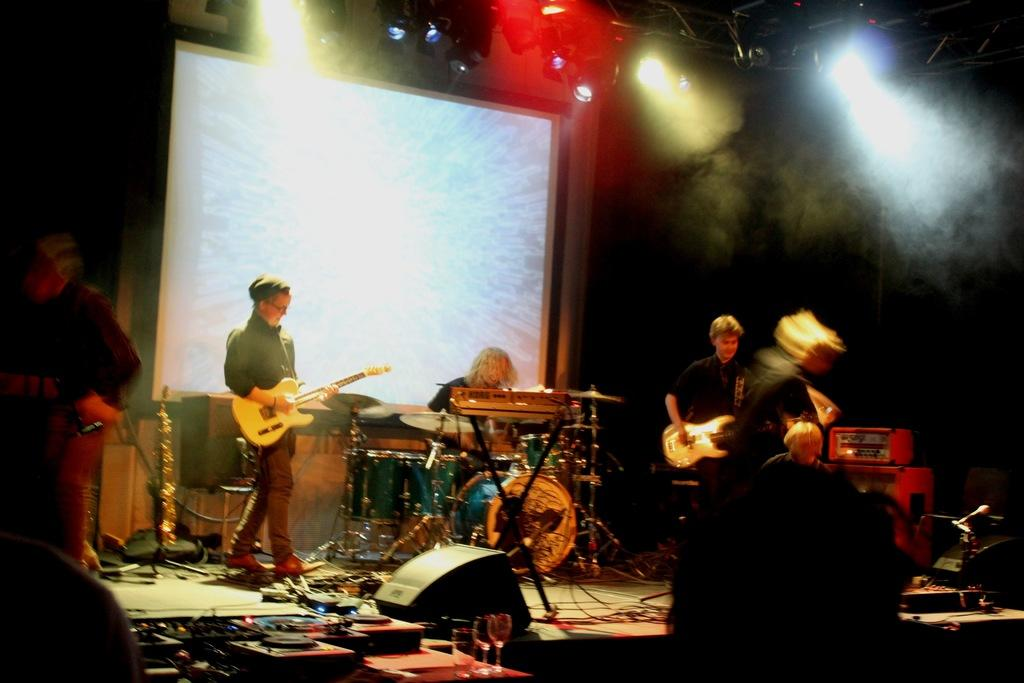What is happening on the stage in the image? There are people on the stage, and they are playing musical instruments. What can be seen in the background of the image? There is a projector in the background. What type of lighting is present in the image? There are multiple colors of lights visible. Where is the bucket of paint located in the image? There is no bucket of paint present in the image. How many planes are flying in the background of the image? There are no planes visible in the image; it only shows people on stage playing musical instruments and a projector in the background. 